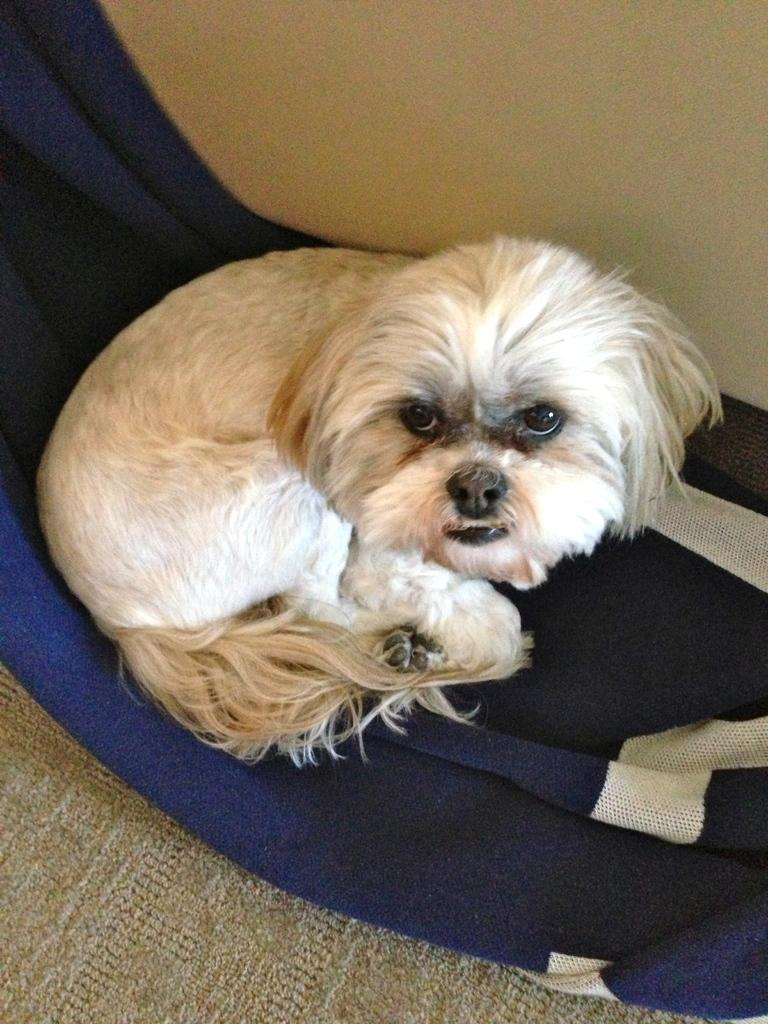What type of animal is in the image? There is a dog in the image. What color is the dog? The dog is white in color. What is the dog sitting on? The dog is sitting on a blue object. What can be seen in the background of the image? There is a wall in the background of the image. What type of railway is visible in the image? There is no railway present in the image; it features a dog sitting on a blue object with a wall in the background. 